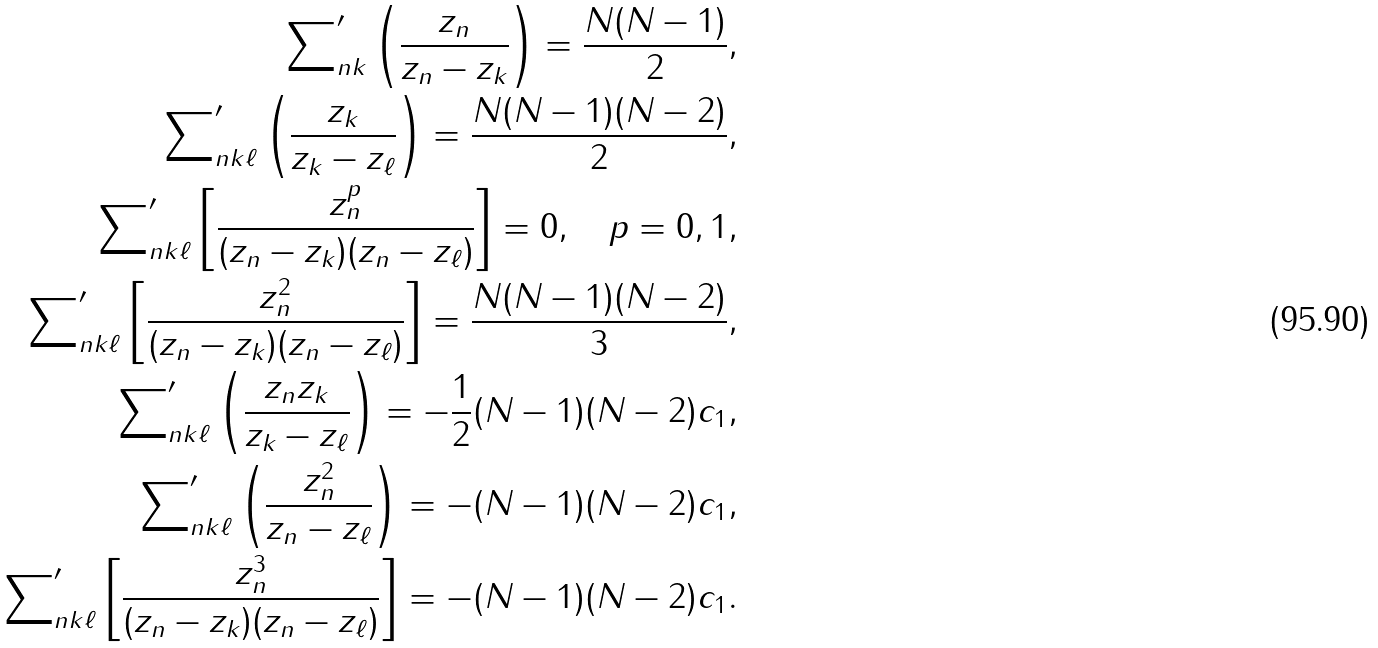<formula> <loc_0><loc_0><loc_500><loc_500>\sum \nolimits _ { n k } ^ { \prime } \left ( \frac { z _ { n } } { z _ { n } - z _ { k } } \right ) = \frac { N ( N - 1 ) } { 2 } , \\ \sum \nolimits _ { n k \ell } ^ { \prime } \left ( \frac { z _ { k } } { z _ { k } - z _ { \ell } } \right ) = \frac { N ( N - 1 ) ( N - 2 ) } { 2 } , \\ \sum \nolimits _ { n k \ell } ^ { \prime } \left [ \frac { z _ { n } ^ { p } } { ( z _ { n } - z _ { k } ) ( z _ { n } - z _ { \ell } ) } \right ] = 0 , \quad p = 0 , 1 , \\ \sum \nolimits _ { n k \ell } ^ { \prime } \left [ \frac { z _ { n } ^ { 2 } } { ( z _ { n } - z _ { k } ) ( z _ { n } - z _ { \ell } ) } \right ] = \frac { N ( N - 1 ) ( N - 2 ) } { 3 } , \\ \sum \nolimits _ { n k \ell } ^ { \prime } \left ( \frac { z _ { n } z _ { k } } { z _ { k } - z _ { \ell } } \right ) = - \frac { 1 } { 2 } ( N - 1 ) ( N - 2 ) c _ { 1 } , \\ \sum \nolimits _ { n k \ell } ^ { \prime } \left ( \frac { z _ { n } ^ { 2 } } { z _ { n } - z _ { \ell } } \right ) = - ( N - 1 ) ( N - 2 ) c _ { 1 } , \\ \sum \nolimits _ { n k \ell } ^ { \prime } \left [ \frac { z _ { n } ^ { 3 } } { ( z _ { n } - z _ { k } ) ( z _ { n } - z _ { \ell } ) } \right ] = - ( N - 1 ) ( N - 2 ) c _ { 1 } .</formula> 